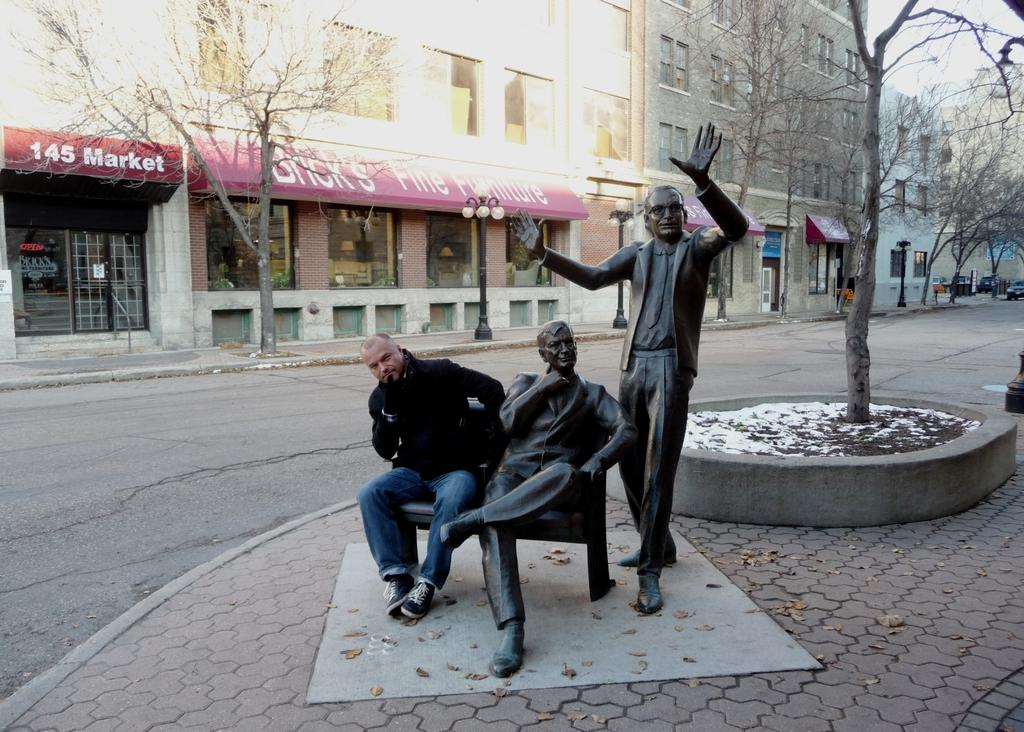What type of structures can be seen in the image? There are buildings in the image. What is the condition of the trees in the image? The trees in the image are dry. How many statues are present in the image? There are two statues in the image. Can you describe the person in the image? There is a man in the image. What type of line is the man using to aid his digestion in the image? There is no line or reference to digestion present in the image; the man is not using any line for that purpose. 